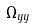<formula> <loc_0><loc_0><loc_500><loc_500>\Omega _ { y y }</formula> 